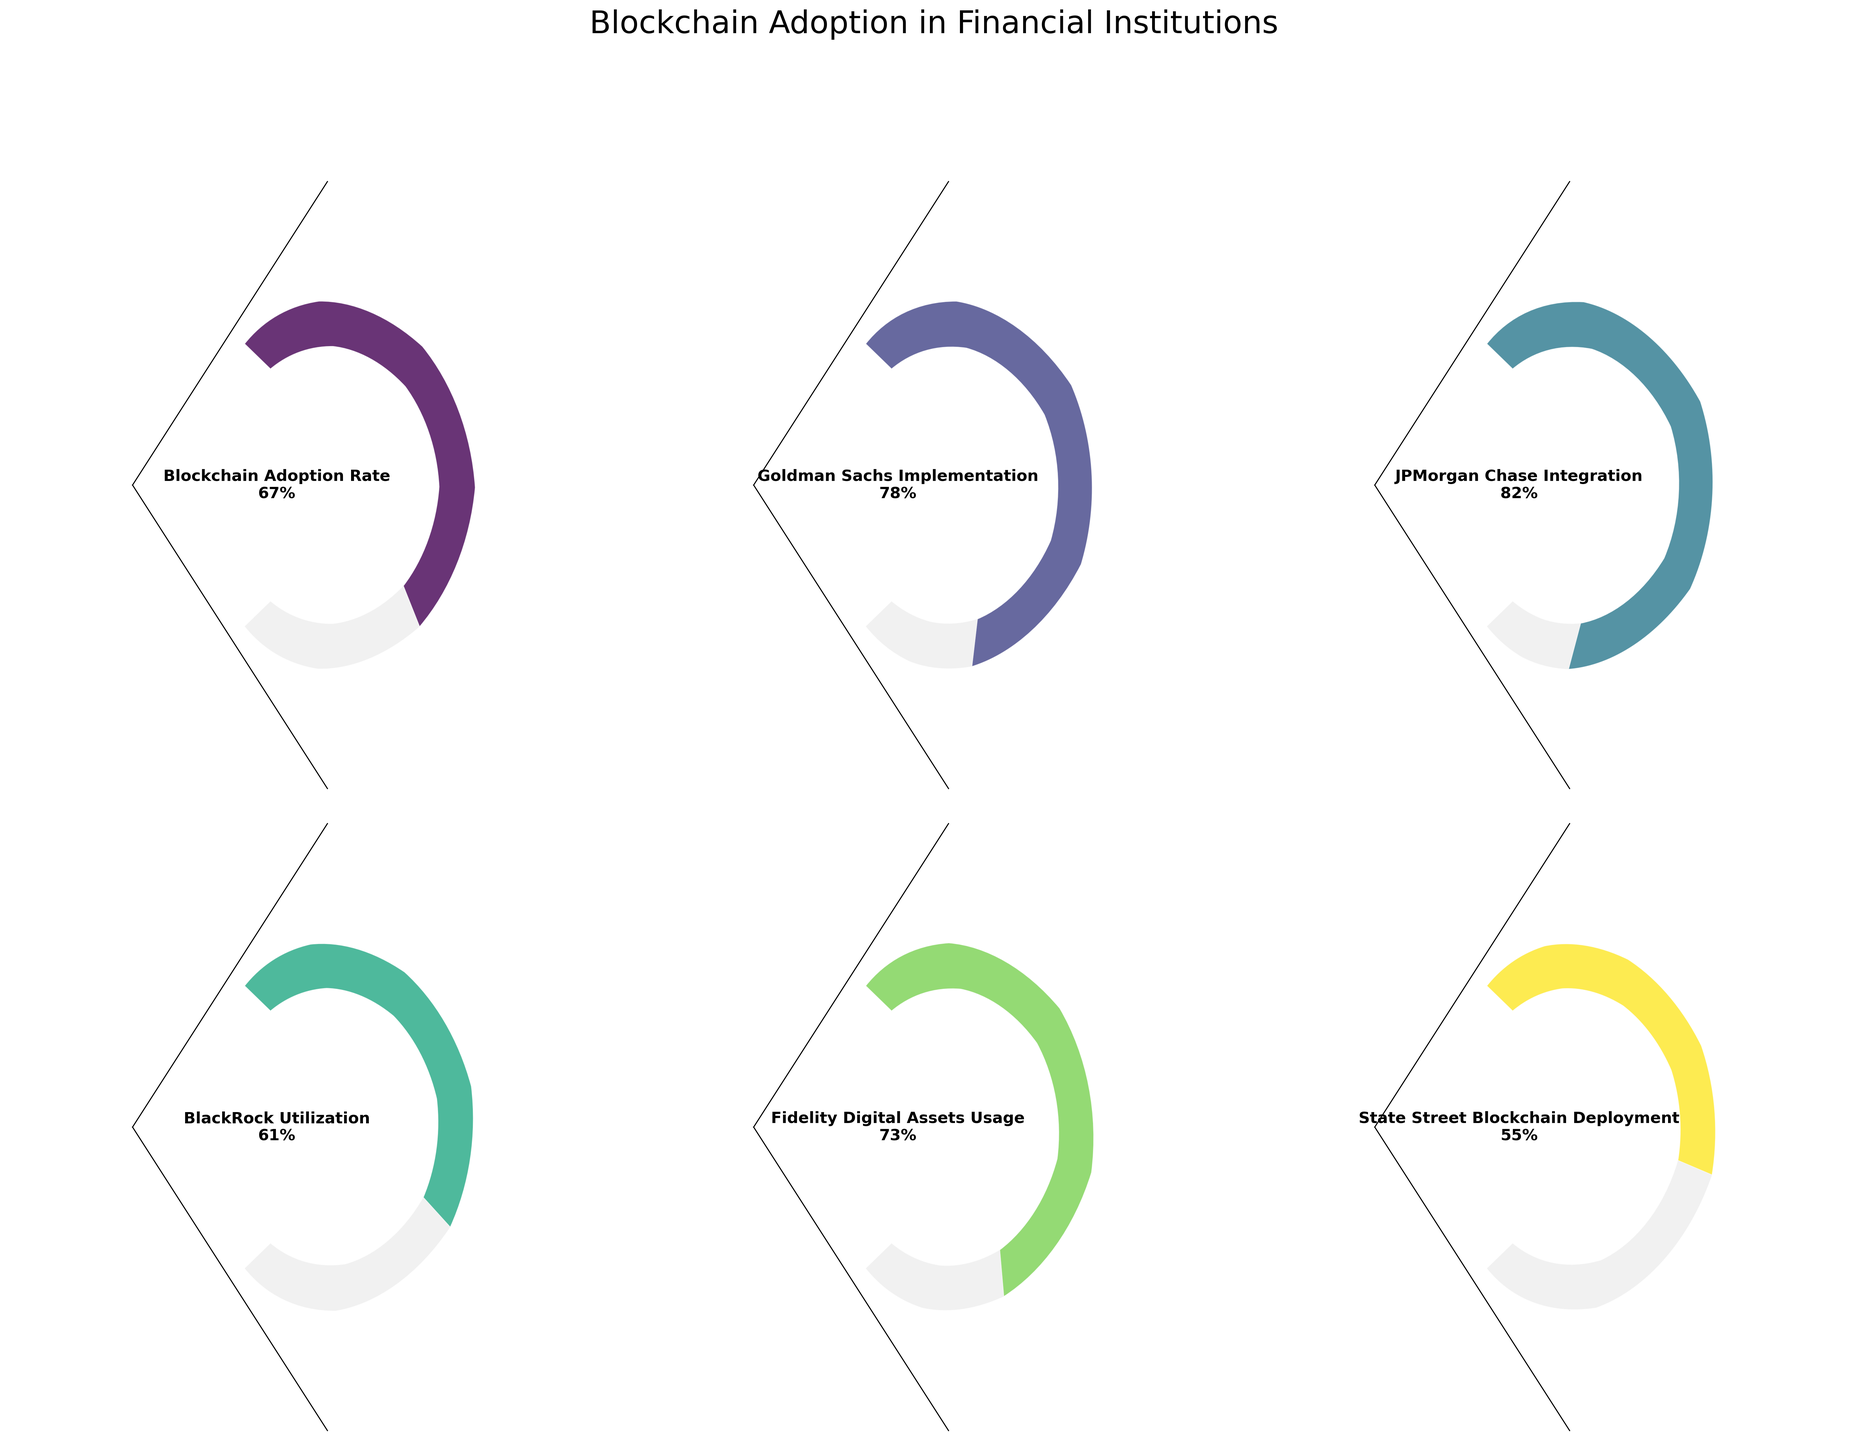How many financial institutions are represented in the chart? The chart consists of 6 gauge charts, each representing a different financial institution. You can count the separate sections to arrive at this number.
Answer: 6 What is the blockchain adoption rate for Fidelity Digital Assets? The gauge chart titled "Fidelity Digital Assets Usage" shows a value of 73%, as annotated in the text within the chart.
Answer: 73% Which financial institution has the highest blockchain adoption rate? The gauge charts provide values for each financial institution. Comparing these, JPMorgan Chase Integration shows the highest value at 82%.
Answer: JPMorgan Chase Integration What is the difference in blockchain adoption rate between BlackRock Utilization and State Street Blockchain Deployment? BlackRock Utilization's gauge chart shows 61%, while State Street Blockchain Deployment's chart shows 55%. The difference is 61 - 55 = 6%.
Answer: 6% What is the average blockchain adoption rate among all the financial institutions represented in the chart? To find the average, sum up the adoption rates (78 + 82 + 61 + 73 + 55) and divide by the number of institutions (6). The sum is 418, so the average is 418 / 6 = 69.67.
Answer: 69.67% Is Goldman Sachs Implementation's blockchain adoption rate above or below the overall average rate? From the previous calculations, the overall average rate is 69.67%. Goldman Sachs Implementation has a rate of 78%, which is above the average.
Answer: Above Which financial institutions have adoption rates below 70%? By examining each gauge chart, BlackRock Utilization (61%), State Street Blockchain Deployment (55%), and Fidelity Digital Assets Usage (73%) have rates below 70%.
Answer: BlackRock Utilization, State Street Blockchain Deployment What fraction of the financial institutions has a blockchain adoption rate greater than 75%? JPMorgan Chase Integration (82%) and Goldman Sachs Implementation (78%) have rates above 75%. There are 6 institutions in total, so the fraction is 2/6 or approximately 1/3.
Answer: 1/3 How does the blockchain adoption rate of BlackRock Utilization compare to the adoption rate of Fidelity Digital Assets Usage? BlackRock Utilization's adoption rate is 61%, whereas Fidelity Digital Assets Usage is 73%. 61% is lower than 73%.
Answer: Lower Calculate the range of blockchain adoption rates among the represented financial institutions. The range is determined by subtracting the minimum rate from the maximum rate. JPMorgan Chase Integration has the highest adoption rate at 82%, and State Street Blockchain Deployment has the lowest at 55%. The range is 82 - 55 = 27%.
Answer: 27% 